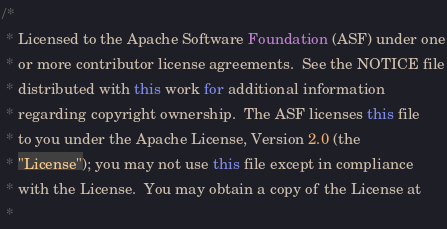Convert code to text. <code><loc_0><loc_0><loc_500><loc_500><_Java_>/*
 * Licensed to the Apache Software Foundation (ASF) under one
 * or more contributor license agreements.  See the NOTICE file
 * distributed with this work for additional information
 * regarding copyright ownership.  The ASF licenses this file
 * to you under the Apache License, Version 2.0 (the
 * "License"); you may not use this file except in compliance
 * with the License.  You may obtain a copy of the License at
 *</code> 